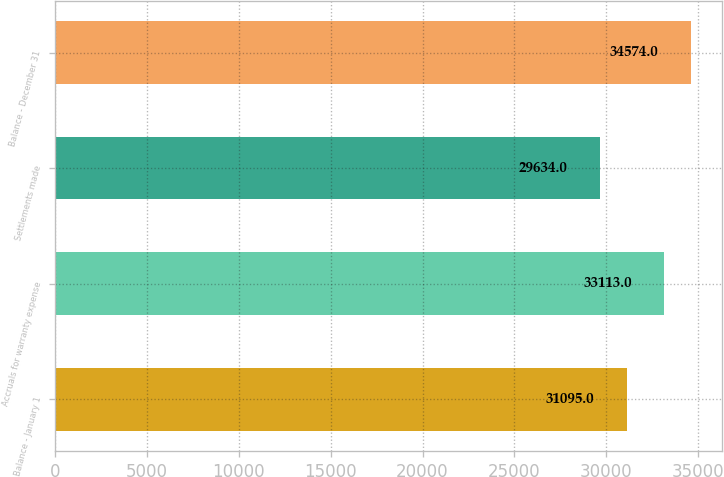<chart> <loc_0><loc_0><loc_500><loc_500><bar_chart><fcel>Balance - January 1<fcel>Accruals for warranty expense<fcel>Settlements made<fcel>Balance - December 31<nl><fcel>31095<fcel>33113<fcel>29634<fcel>34574<nl></chart> 